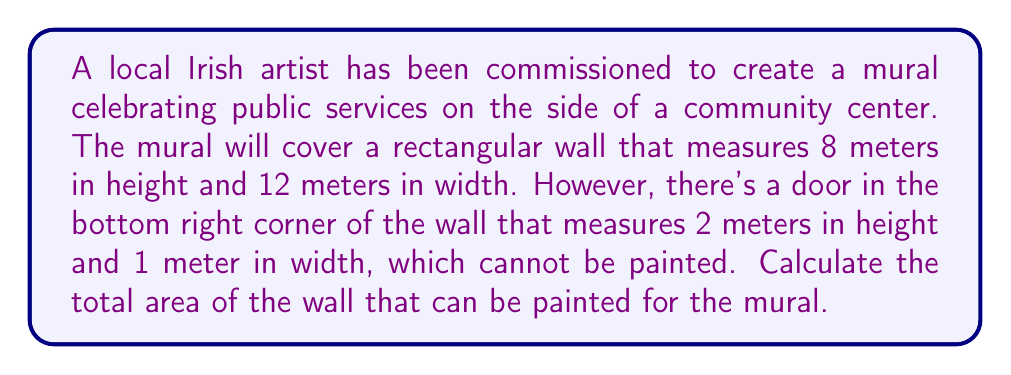Teach me how to tackle this problem. To solve this problem, we need to follow these steps:

1. Calculate the total area of the rectangular wall:
   $$A_{wall} = height \times width$$
   $$A_{wall} = 8 \text{ m} \times 12 \text{ m} = 96 \text{ m}^2$$

2. Calculate the area of the door:
   $$A_{door} = height \times width$$
   $$A_{door} = 2 \text{ m} \times 1 \text{ m} = 2 \text{ m}^2$$

3. Subtract the area of the door from the total wall area to get the paintable area:
   $$A_{mural} = A_{wall} - A_{door}$$
   $$A_{mural} = 96 \text{ m}^2 - 2 \text{ m}^2 = 94 \text{ m}^2$$

[asy]
import geometry;

size(200);
pair A = (0,0), B = (12,0), C = (12,8), D = (0,8);
pair E = (11,0), F = (12,0), G = (12,2), H = (11,2);

draw(A--B--C--D--cycle);
draw(E--F--G--H--cycle);

label("8 m", (0,4), W);
label("12 m", (6,0), S);
label("2 m", (12,1), E);
label("1 m", (11.5,0), S);

[/asy]
Answer: The total area that can be painted for the mural is $94 \text{ m}^2$. 